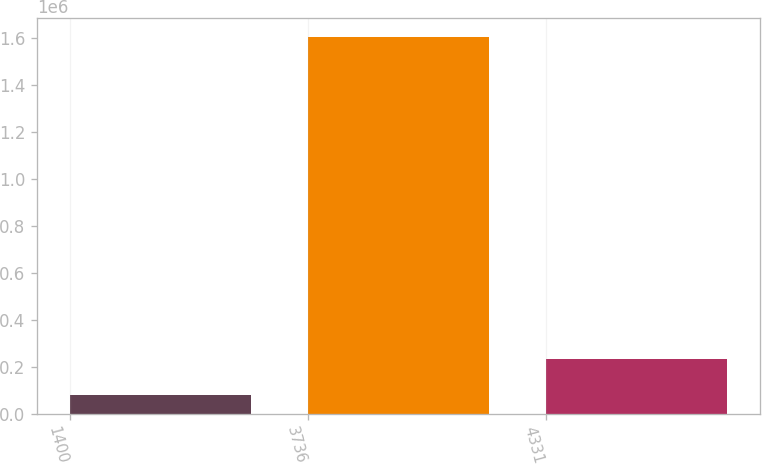<chart> <loc_0><loc_0><loc_500><loc_500><bar_chart><fcel>1400<fcel>3736<fcel>4331<nl><fcel>80636<fcel>1.60378e+06<fcel>232950<nl></chart> 